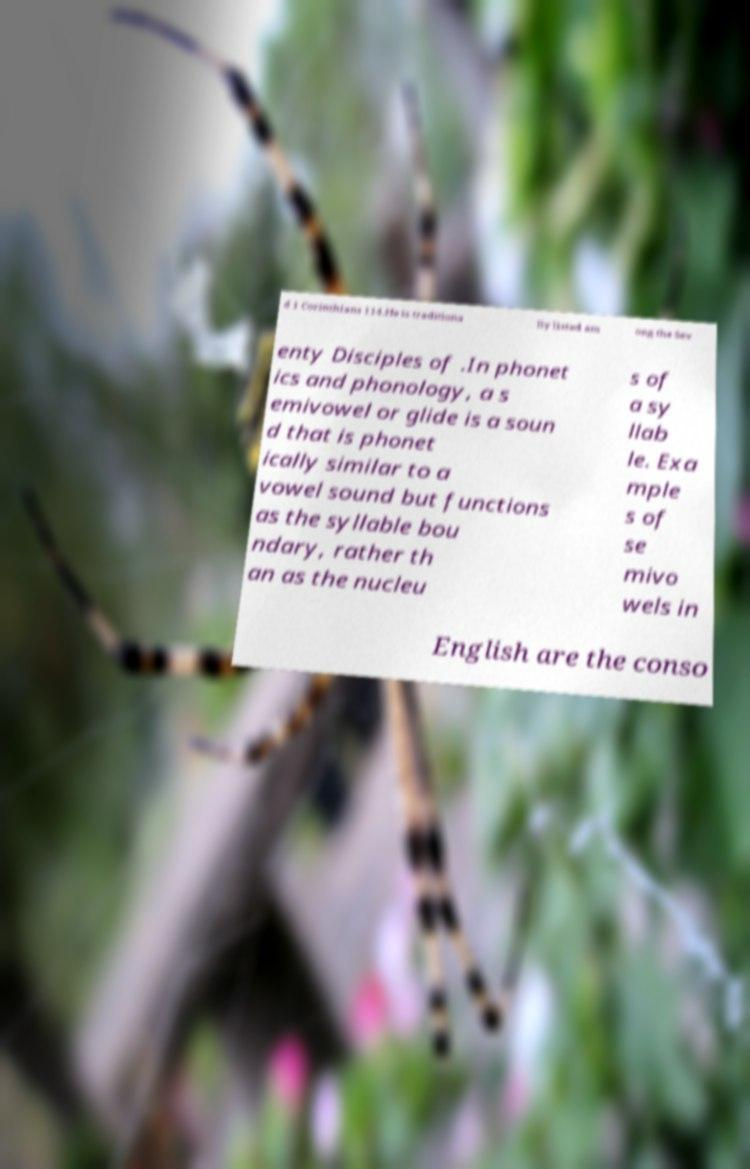Can you accurately transcribe the text from the provided image for me? d 1 Corinthians 114.He is traditiona lly listed am ong the Sev enty Disciples of .In phonet ics and phonology, a s emivowel or glide is a soun d that is phonet ically similar to a vowel sound but functions as the syllable bou ndary, rather th an as the nucleu s of a sy llab le. Exa mple s of se mivo wels in English are the conso 